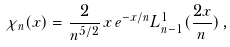<formula> <loc_0><loc_0><loc_500><loc_500>\chi _ { n } ( x ) = \frac { 2 } { n ^ { 5 / 2 } } \, x \, e ^ { - x / n } L _ { n - 1 } ^ { 1 } ( \frac { 2 x } { n } ) \, ,</formula> 